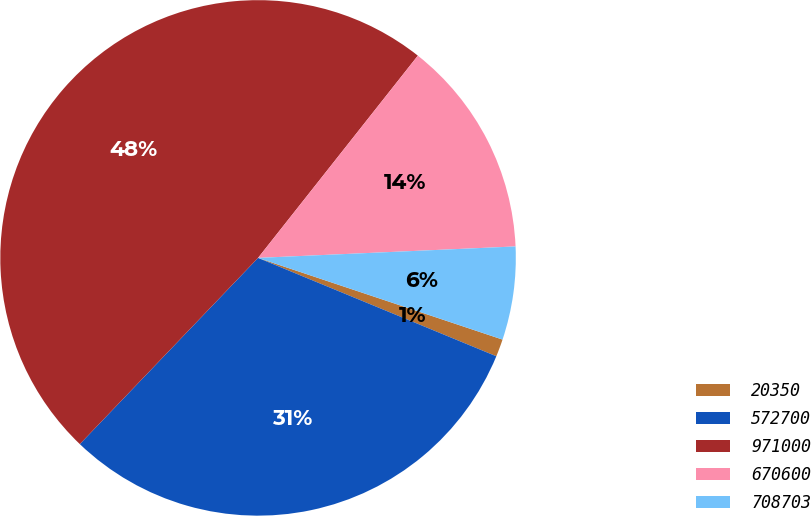<chart> <loc_0><loc_0><loc_500><loc_500><pie_chart><fcel>20350<fcel>572700<fcel>971000<fcel>670600<fcel>708703<nl><fcel>1.1%<fcel>30.92%<fcel>48.49%<fcel>13.65%<fcel>5.84%<nl></chart> 